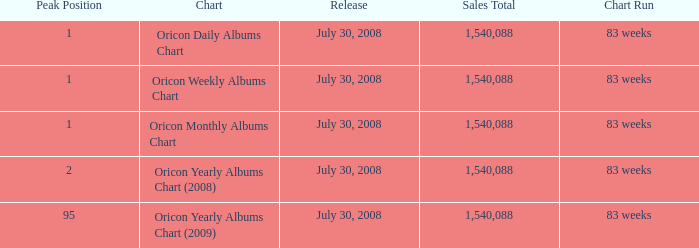Which Chart has a Peak Position of 1? Oricon Daily Albums Chart, Oricon Weekly Albums Chart, Oricon Monthly Albums Chart. Can you give me this table as a dict? {'header': ['Peak Position', 'Chart', 'Release', 'Sales Total', 'Chart Run'], 'rows': [['1', 'Oricon Daily Albums Chart', 'July 30, 2008', '1,540,088', '83 weeks'], ['1', 'Oricon Weekly Albums Chart', 'July 30, 2008', '1,540,088', '83 weeks'], ['1', 'Oricon Monthly Albums Chart', 'July 30, 2008', '1,540,088', '83 weeks'], ['2', 'Oricon Yearly Albums Chart (2008)', 'July 30, 2008', '1,540,088', '83 weeks'], ['95', 'Oricon Yearly Albums Chart (2009)', 'July 30, 2008', '1,540,088', '83 weeks']]} 